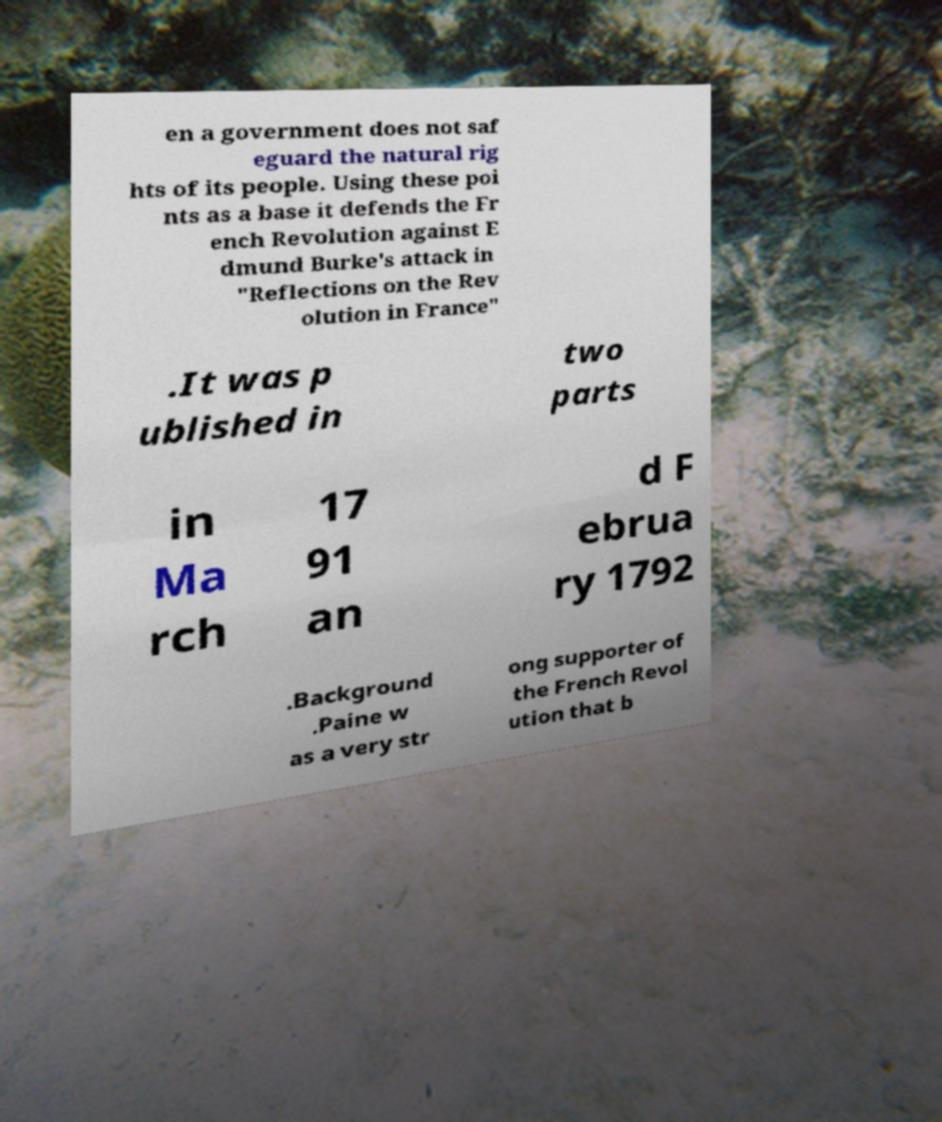For documentation purposes, I need the text within this image transcribed. Could you provide that? en a government does not saf eguard the natural rig hts of its people. Using these poi nts as a base it defends the Fr ench Revolution against E dmund Burke's attack in "Reflections on the Rev olution in France" .It was p ublished in two parts in Ma rch 17 91 an d F ebrua ry 1792 .Background .Paine w as a very str ong supporter of the French Revol ution that b 